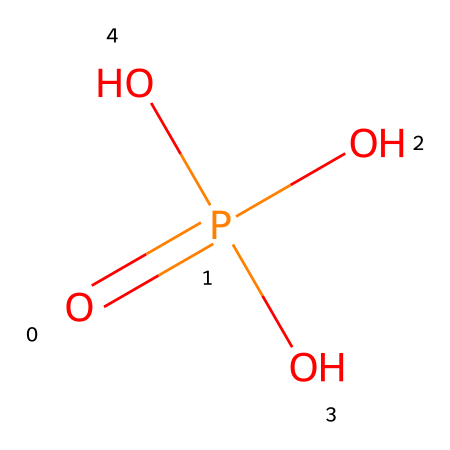What is the central atom in this compound? The structure shows phosphorus (P) as the central atom, where it is bonded to four oxygen atoms. This indicates that phosphorus is the main element around which the structure is organized.
Answer: phosphorus How many oxygen atoms are present in this molecule? The chemical structure represents three hydroxyl (OH) groups and one double-bonded oxygen (O=), totaling four oxygen atoms.
Answer: four What type of functional group is present in phosphoric acid? The presence of multiple hydroxyl (OH) groups indicates that this compound is a type of alcohol, specifically a triol due to the three hydroxyl groups.
Answer: triol What is the oxidation state of phosphorus in this compound? To determine the oxidation state of phosphorus, consider that each of the three oxygen atoms in hydroxyl groups has an oxidation state of -2, leading to a total of -6 from three oxygens, and the double bond contributes -2. Thus, phosphorus must be +5 to balance the entire molecule to neutral.
Answer: +5 How many hydrogen atoms are in the molecular formula of this compound? Each hydroxyl group contains one hydrogen atom, and there are three such groups in the structure. Thus, there are a total of three hydrogen atoms in the molecular formula.
Answer: three What role does phosphoric acid play in cola beverages? Phosphoric acid serves a key role in flavor enhancement and acts as a preservative in cola beverages, contributing to the beverage's tartness and also providing acidity.
Answer: flavor enhancer 